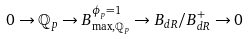<formula> <loc_0><loc_0><loc_500><loc_500>0 \to \mathbb { Q } _ { p } \to B _ { \max , \mathbb { Q } _ { p } } ^ { \phi _ { p } = 1 } \to B _ { d R } / B ^ { + } _ { d R } \to 0</formula> 